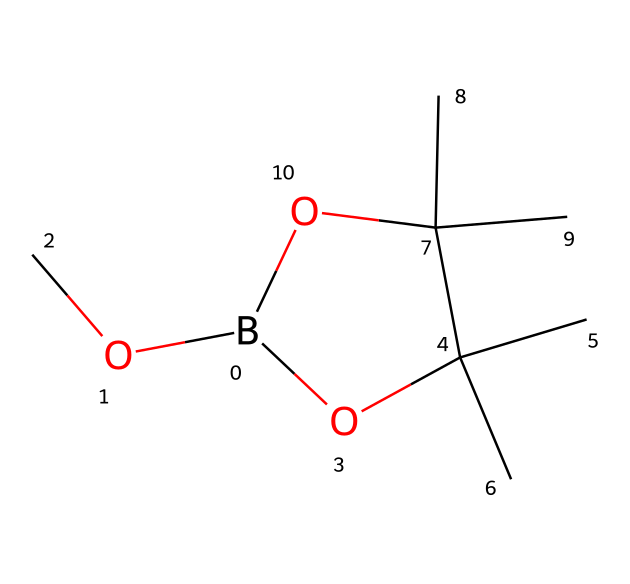What is the central atom in this compound? The structure indicates that boron (B) is the central atom, as it is the main element present in boranes, which typically contain boron as the primary component.
Answer: boron How many carbon atoms are present in this structure? By analyzing the SMILES representation, there are six carbon (C) atoms visible in the branched structure.
Answer: six What functional groups are present in this compound? The structure contains two hydroxyl groups (-OH) and ether linkages (C-O-C), which are evident from the multiple oxygen atoms and their connectivity with carbon atoms.
Answer: hydroxyl, ether What is the degree of saturation of this compound? To determine the degree of saturation, we count the number of rings and multiple bonds. The presence of one ring structure indicates a degree of saturation of one.
Answer: one Does this compound conform to the typical structure of boranes? Yes, this compound has the characteristic boron and carbon structure combined with oxygen, aligning with the typical borane properties, which may have complex structures when substituted.
Answer: yes Is this compound a potential candidate for patenting in pharmaceuticals? Given its novel structure and the presence of functional groups that can aid biological activity, this compound may have potential as a pharmaceutical candidate, which is often a factor in patenting decisions.
Answer: yes 